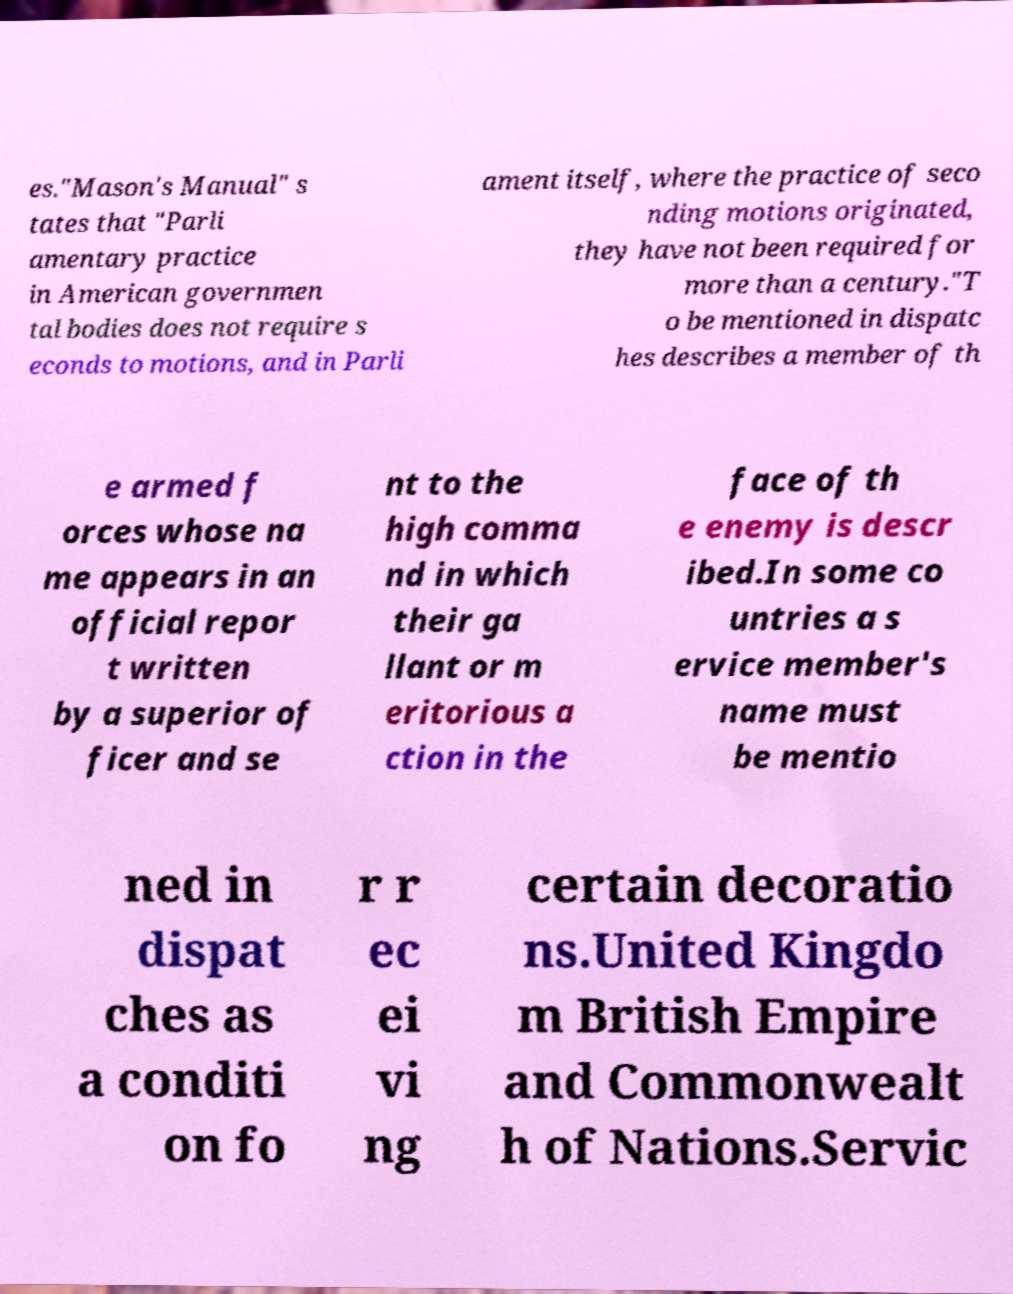Could you extract and type out the text from this image? es."Mason's Manual" s tates that "Parli amentary practice in American governmen tal bodies does not require s econds to motions, and in Parli ament itself, where the practice of seco nding motions originated, they have not been required for more than a century."T o be mentioned in dispatc hes describes a member of th e armed f orces whose na me appears in an official repor t written by a superior of ficer and se nt to the high comma nd in which their ga llant or m eritorious a ction in the face of th e enemy is descr ibed.In some co untries a s ervice member's name must be mentio ned in dispat ches as a conditi on fo r r ec ei vi ng certain decoratio ns.United Kingdo m British Empire and Commonwealt h of Nations.Servic 